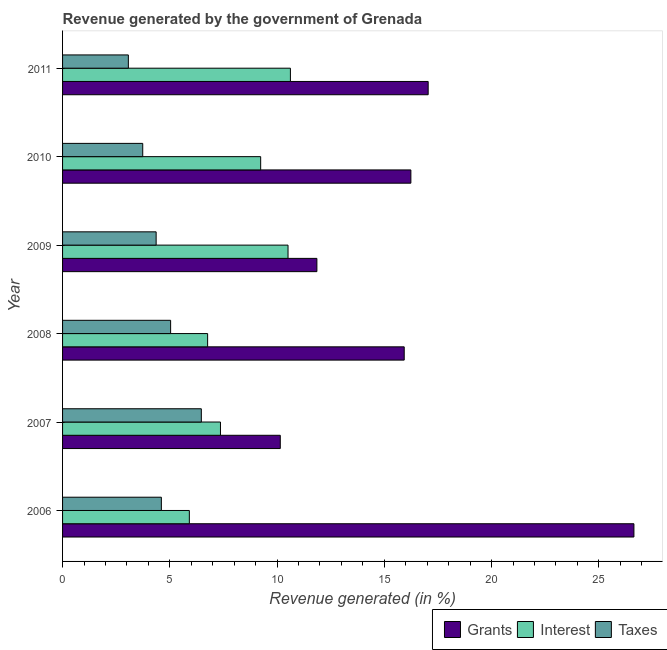What is the label of the 6th group of bars from the top?
Provide a short and direct response. 2006. What is the percentage of revenue generated by grants in 2008?
Your answer should be very brief. 15.93. Across all years, what is the maximum percentage of revenue generated by interest?
Your answer should be compact. 10.62. Across all years, what is the minimum percentage of revenue generated by taxes?
Your response must be concise. 3.07. In which year was the percentage of revenue generated by interest minimum?
Make the answer very short. 2006. What is the total percentage of revenue generated by interest in the graph?
Provide a short and direct response. 50.4. What is the difference between the percentage of revenue generated by taxes in 2006 and that in 2007?
Keep it short and to the point. -1.86. What is the difference between the percentage of revenue generated by grants in 2010 and the percentage of revenue generated by taxes in 2009?
Offer a terse response. 11.88. In the year 2011, what is the difference between the percentage of revenue generated by taxes and percentage of revenue generated by interest?
Give a very brief answer. -7.55. What is the ratio of the percentage of revenue generated by grants in 2006 to that in 2011?
Give a very brief answer. 1.56. What is the difference between the highest and the second highest percentage of revenue generated by taxes?
Make the answer very short. 1.43. What is the difference between the highest and the lowest percentage of revenue generated by grants?
Your answer should be very brief. 16.49. What does the 1st bar from the top in 2008 represents?
Your answer should be very brief. Taxes. What does the 3rd bar from the bottom in 2008 represents?
Provide a short and direct response. Taxes. Is it the case that in every year, the sum of the percentage of revenue generated by grants and percentage of revenue generated by interest is greater than the percentage of revenue generated by taxes?
Keep it short and to the point. Yes. Are all the bars in the graph horizontal?
Offer a very short reply. Yes. How many years are there in the graph?
Keep it short and to the point. 6. Does the graph contain any zero values?
Provide a succinct answer. No. How many legend labels are there?
Provide a succinct answer. 3. What is the title of the graph?
Make the answer very short. Revenue generated by the government of Grenada. What is the label or title of the X-axis?
Ensure brevity in your answer.  Revenue generated (in %). What is the Revenue generated (in %) of Grants in 2006?
Ensure brevity in your answer.  26.64. What is the Revenue generated (in %) of Interest in 2006?
Give a very brief answer. 5.91. What is the Revenue generated (in %) in Taxes in 2006?
Make the answer very short. 4.61. What is the Revenue generated (in %) of Grants in 2007?
Make the answer very short. 10.15. What is the Revenue generated (in %) in Interest in 2007?
Provide a succinct answer. 7.36. What is the Revenue generated (in %) in Taxes in 2007?
Offer a very short reply. 6.47. What is the Revenue generated (in %) of Grants in 2008?
Offer a terse response. 15.93. What is the Revenue generated (in %) in Interest in 2008?
Make the answer very short. 6.76. What is the Revenue generated (in %) in Taxes in 2008?
Offer a terse response. 5.04. What is the Revenue generated (in %) of Grants in 2009?
Offer a terse response. 11.86. What is the Revenue generated (in %) in Interest in 2009?
Give a very brief answer. 10.51. What is the Revenue generated (in %) in Taxes in 2009?
Provide a short and direct response. 4.36. What is the Revenue generated (in %) of Grants in 2010?
Your answer should be very brief. 16.24. What is the Revenue generated (in %) of Interest in 2010?
Keep it short and to the point. 9.24. What is the Revenue generated (in %) of Taxes in 2010?
Offer a terse response. 3.74. What is the Revenue generated (in %) in Grants in 2011?
Your answer should be compact. 17.04. What is the Revenue generated (in %) of Interest in 2011?
Offer a very short reply. 10.62. What is the Revenue generated (in %) of Taxes in 2011?
Ensure brevity in your answer.  3.07. Across all years, what is the maximum Revenue generated (in %) in Grants?
Keep it short and to the point. 26.64. Across all years, what is the maximum Revenue generated (in %) in Interest?
Ensure brevity in your answer.  10.62. Across all years, what is the maximum Revenue generated (in %) of Taxes?
Provide a succinct answer. 6.47. Across all years, what is the minimum Revenue generated (in %) in Grants?
Provide a succinct answer. 10.15. Across all years, what is the minimum Revenue generated (in %) of Interest?
Provide a succinct answer. 5.91. Across all years, what is the minimum Revenue generated (in %) in Taxes?
Give a very brief answer. 3.07. What is the total Revenue generated (in %) in Grants in the graph?
Make the answer very short. 97.85. What is the total Revenue generated (in %) in Interest in the graph?
Make the answer very short. 50.4. What is the total Revenue generated (in %) of Taxes in the graph?
Make the answer very short. 27.28. What is the difference between the Revenue generated (in %) in Grants in 2006 and that in 2007?
Ensure brevity in your answer.  16.49. What is the difference between the Revenue generated (in %) of Interest in 2006 and that in 2007?
Offer a very short reply. -1.45. What is the difference between the Revenue generated (in %) of Taxes in 2006 and that in 2007?
Provide a succinct answer. -1.86. What is the difference between the Revenue generated (in %) in Grants in 2006 and that in 2008?
Make the answer very short. 10.71. What is the difference between the Revenue generated (in %) of Interest in 2006 and that in 2008?
Provide a succinct answer. -0.85. What is the difference between the Revenue generated (in %) of Taxes in 2006 and that in 2008?
Offer a terse response. -0.43. What is the difference between the Revenue generated (in %) of Grants in 2006 and that in 2009?
Provide a succinct answer. 14.78. What is the difference between the Revenue generated (in %) of Interest in 2006 and that in 2009?
Your answer should be very brief. -4.6. What is the difference between the Revenue generated (in %) of Taxes in 2006 and that in 2009?
Keep it short and to the point. 0.24. What is the difference between the Revenue generated (in %) of Grants in 2006 and that in 2010?
Offer a terse response. 10.4. What is the difference between the Revenue generated (in %) of Interest in 2006 and that in 2010?
Offer a terse response. -3.33. What is the difference between the Revenue generated (in %) of Taxes in 2006 and that in 2010?
Your answer should be compact. 0.87. What is the difference between the Revenue generated (in %) in Grants in 2006 and that in 2011?
Offer a terse response. 9.59. What is the difference between the Revenue generated (in %) in Interest in 2006 and that in 2011?
Your answer should be very brief. -4.71. What is the difference between the Revenue generated (in %) in Taxes in 2006 and that in 2011?
Your answer should be very brief. 1.54. What is the difference between the Revenue generated (in %) in Grants in 2007 and that in 2008?
Your response must be concise. -5.78. What is the difference between the Revenue generated (in %) in Interest in 2007 and that in 2008?
Provide a short and direct response. 0.6. What is the difference between the Revenue generated (in %) in Taxes in 2007 and that in 2008?
Your answer should be very brief. 1.43. What is the difference between the Revenue generated (in %) of Grants in 2007 and that in 2009?
Ensure brevity in your answer.  -1.71. What is the difference between the Revenue generated (in %) in Interest in 2007 and that in 2009?
Your response must be concise. -3.15. What is the difference between the Revenue generated (in %) of Taxes in 2007 and that in 2009?
Keep it short and to the point. 2.11. What is the difference between the Revenue generated (in %) in Grants in 2007 and that in 2010?
Provide a succinct answer. -6.09. What is the difference between the Revenue generated (in %) of Interest in 2007 and that in 2010?
Keep it short and to the point. -1.87. What is the difference between the Revenue generated (in %) in Taxes in 2007 and that in 2010?
Your response must be concise. 2.73. What is the difference between the Revenue generated (in %) in Grants in 2007 and that in 2011?
Make the answer very short. -6.89. What is the difference between the Revenue generated (in %) in Interest in 2007 and that in 2011?
Your response must be concise. -3.26. What is the difference between the Revenue generated (in %) in Taxes in 2007 and that in 2011?
Keep it short and to the point. 3.4. What is the difference between the Revenue generated (in %) in Grants in 2008 and that in 2009?
Your answer should be very brief. 4.07. What is the difference between the Revenue generated (in %) of Interest in 2008 and that in 2009?
Your answer should be compact. -3.75. What is the difference between the Revenue generated (in %) of Taxes in 2008 and that in 2009?
Keep it short and to the point. 0.68. What is the difference between the Revenue generated (in %) of Grants in 2008 and that in 2010?
Your answer should be compact. -0.31. What is the difference between the Revenue generated (in %) in Interest in 2008 and that in 2010?
Your answer should be compact. -2.47. What is the difference between the Revenue generated (in %) of Taxes in 2008 and that in 2010?
Offer a terse response. 1.3. What is the difference between the Revenue generated (in %) in Grants in 2008 and that in 2011?
Your response must be concise. -1.12. What is the difference between the Revenue generated (in %) of Interest in 2008 and that in 2011?
Offer a very short reply. -3.86. What is the difference between the Revenue generated (in %) of Taxes in 2008 and that in 2011?
Offer a very short reply. 1.97. What is the difference between the Revenue generated (in %) of Grants in 2009 and that in 2010?
Provide a short and direct response. -4.38. What is the difference between the Revenue generated (in %) in Interest in 2009 and that in 2010?
Your response must be concise. 1.27. What is the difference between the Revenue generated (in %) of Taxes in 2009 and that in 2010?
Make the answer very short. 0.62. What is the difference between the Revenue generated (in %) in Grants in 2009 and that in 2011?
Offer a terse response. -5.19. What is the difference between the Revenue generated (in %) in Interest in 2009 and that in 2011?
Provide a succinct answer. -0.11. What is the difference between the Revenue generated (in %) in Taxes in 2009 and that in 2011?
Your answer should be very brief. 1.29. What is the difference between the Revenue generated (in %) in Grants in 2010 and that in 2011?
Your answer should be very brief. -0.81. What is the difference between the Revenue generated (in %) of Interest in 2010 and that in 2011?
Ensure brevity in your answer.  -1.39. What is the difference between the Revenue generated (in %) of Taxes in 2010 and that in 2011?
Offer a terse response. 0.67. What is the difference between the Revenue generated (in %) in Grants in 2006 and the Revenue generated (in %) in Interest in 2007?
Your answer should be compact. 19.27. What is the difference between the Revenue generated (in %) of Grants in 2006 and the Revenue generated (in %) of Taxes in 2007?
Your response must be concise. 20.17. What is the difference between the Revenue generated (in %) in Interest in 2006 and the Revenue generated (in %) in Taxes in 2007?
Give a very brief answer. -0.56. What is the difference between the Revenue generated (in %) of Grants in 2006 and the Revenue generated (in %) of Interest in 2008?
Your answer should be very brief. 19.87. What is the difference between the Revenue generated (in %) in Grants in 2006 and the Revenue generated (in %) in Taxes in 2008?
Make the answer very short. 21.6. What is the difference between the Revenue generated (in %) of Interest in 2006 and the Revenue generated (in %) of Taxes in 2008?
Provide a succinct answer. 0.87. What is the difference between the Revenue generated (in %) of Grants in 2006 and the Revenue generated (in %) of Interest in 2009?
Your response must be concise. 16.12. What is the difference between the Revenue generated (in %) of Grants in 2006 and the Revenue generated (in %) of Taxes in 2009?
Your answer should be very brief. 22.27. What is the difference between the Revenue generated (in %) in Interest in 2006 and the Revenue generated (in %) in Taxes in 2009?
Your answer should be compact. 1.55. What is the difference between the Revenue generated (in %) of Grants in 2006 and the Revenue generated (in %) of Interest in 2010?
Ensure brevity in your answer.  17.4. What is the difference between the Revenue generated (in %) of Grants in 2006 and the Revenue generated (in %) of Taxes in 2010?
Offer a terse response. 22.9. What is the difference between the Revenue generated (in %) in Interest in 2006 and the Revenue generated (in %) in Taxes in 2010?
Give a very brief answer. 2.17. What is the difference between the Revenue generated (in %) of Grants in 2006 and the Revenue generated (in %) of Interest in 2011?
Provide a short and direct response. 16.01. What is the difference between the Revenue generated (in %) in Grants in 2006 and the Revenue generated (in %) in Taxes in 2011?
Offer a very short reply. 23.57. What is the difference between the Revenue generated (in %) of Interest in 2006 and the Revenue generated (in %) of Taxes in 2011?
Your response must be concise. 2.84. What is the difference between the Revenue generated (in %) in Grants in 2007 and the Revenue generated (in %) in Interest in 2008?
Give a very brief answer. 3.39. What is the difference between the Revenue generated (in %) in Grants in 2007 and the Revenue generated (in %) in Taxes in 2008?
Your answer should be compact. 5.11. What is the difference between the Revenue generated (in %) of Interest in 2007 and the Revenue generated (in %) of Taxes in 2008?
Provide a short and direct response. 2.32. What is the difference between the Revenue generated (in %) of Grants in 2007 and the Revenue generated (in %) of Interest in 2009?
Your answer should be compact. -0.36. What is the difference between the Revenue generated (in %) of Grants in 2007 and the Revenue generated (in %) of Taxes in 2009?
Offer a terse response. 5.79. What is the difference between the Revenue generated (in %) in Interest in 2007 and the Revenue generated (in %) in Taxes in 2009?
Ensure brevity in your answer.  3. What is the difference between the Revenue generated (in %) of Grants in 2007 and the Revenue generated (in %) of Interest in 2010?
Keep it short and to the point. 0.91. What is the difference between the Revenue generated (in %) in Grants in 2007 and the Revenue generated (in %) in Taxes in 2010?
Give a very brief answer. 6.41. What is the difference between the Revenue generated (in %) of Interest in 2007 and the Revenue generated (in %) of Taxes in 2010?
Offer a very short reply. 3.62. What is the difference between the Revenue generated (in %) in Grants in 2007 and the Revenue generated (in %) in Interest in 2011?
Offer a terse response. -0.47. What is the difference between the Revenue generated (in %) of Grants in 2007 and the Revenue generated (in %) of Taxes in 2011?
Give a very brief answer. 7.08. What is the difference between the Revenue generated (in %) in Interest in 2007 and the Revenue generated (in %) in Taxes in 2011?
Give a very brief answer. 4.29. What is the difference between the Revenue generated (in %) in Grants in 2008 and the Revenue generated (in %) in Interest in 2009?
Provide a short and direct response. 5.42. What is the difference between the Revenue generated (in %) in Grants in 2008 and the Revenue generated (in %) in Taxes in 2009?
Provide a short and direct response. 11.57. What is the difference between the Revenue generated (in %) in Interest in 2008 and the Revenue generated (in %) in Taxes in 2009?
Offer a terse response. 2.4. What is the difference between the Revenue generated (in %) in Grants in 2008 and the Revenue generated (in %) in Interest in 2010?
Your response must be concise. 6.69. What is the difference between the Revenue generated (in %) of Grants in 2008 and the Revenue generated (in %) of Taxes in 2010?
Your answer should be compact. 12.19. What is the difference between the Revenue generated (in %) in Interest in 2008 and the Revenue generated (in %) in Taxes in 2010?
Your answer should be very brief. 3.03. What is the difference between the Revenue generated (in %) of Grants in 2008 and the Revenue generated (in %) of Interest in 2011?
Keep it short and to the point. 5.31. What is the difference between the Revenue generated (in %) in Grants in 2008 and the Revenue generated (in %) in Taxes in 2011?
Make the answer very short. 12.86. What is the difference between the Revenue generated (in %) of Interest in 2008 and the Revenue generated (in %) of Taxes in 2011?
Offer a very short reply. 3.7. What is the difference between the Revenue generated (in %) of Grants in 2009 and the Revenue generated (in %) of Interest in 2010?
Your response must be concise. 2.62. What is the difference between the Revenue generated (in %) of Grants in 2009 and the Revenue generated (in %) of Taxes in 2010?
Provide a short and direct response. 8.12. What is the difference between the Revenue generated (in %) in Interest in 2009 and the Revenue generated (in %) in Taxes in 2010?
Provide a short and direct response. 6.77. What is the difference between the Revenue generated (in %) of Grants in 2009 and the Revenue generated (in %) of Interest in 2011?
Keep it short and to the point. 1.23. What is the difference between the Revenue generated (in %) in Grants in 2009 and the Revenue generated (in %) in Taxes in 2011?
Your answer should be very brief. 8.79. What is the difference between the Revenue generated (in %) of Interest in 2009 and the Revenue generated (in %) of Taxes in 2011?
Your answer should be compact. 7.44. What is the difference between the Revenue generated (in %) in Grants in 2010 and the Revenue generated (in %) in Interest in 2011?
Offer a very short reply. 5.62. What is the difference between the Revenue generated (in %) of Grants in 2010 and the Revenue generated (in %) of Taxes in 2011?
Ensure brevity in your answer.  13.17. What is the difference between the Revenue generated (in %) of Interest in 2010 and the Revenue generated (in %) of Taxes in 2011?
Your answer should be compact. 6.17. What is the average Revenue generated (in %) of Grants per year?
Ensure brevity in your answer.  16.31. What is the average Revenue generated (in %) of Interest per year?
Ensure brevity in your answer.  8.4. What is the average Revenue generated (in %) of Taxes per year?
Ensure brevity in your answer.  4.55. In the year 2006, what is the difference between the Revenue generated (in %) of Grants and Revenue generated (in %) of Interest?
Provide a succinct answer. 20.73. In the year 2006, what is the difference between the Revenue generated (in %) in Grants and Revenue generated (in %) in Taxes?
Ensure brevity in your answer.  22.03. In the year 2006, what is the difference between the Revenue generated (in %) of Interest and Revenue generated (in %) of Taxes?
Provide a succinct answer. 1.3. In the year 2007, what is the difference between the Revenue generated (in %) of Grants and Revenue generated (in %) of Interest?
Make the answer very short. 2.79. In the year 2007, what is the difference between the Revenue generated (in %) in Grants and Revenue generated (in %) in Taxes?
Offer a terse response. 3.68. In the year 2007, what is the difference between the Revenue generated (in %) in Interest and Revenue generated (in %) in Taxes?
Offer a very short reply. 0.89. In the year 2008, what is the difference between the Revenue generated (in %) in Grants and Revenue generated (in %) in Interest?
Offer a very short reply. 9.16. In the year 2008, what is the difference between the Revenue generated (in %) of Grants and Revenue generated (in %) of Taxes?
Ensure brevity in your answer.  10.89. In the year 2008, what is the difference between the Revenue generated (in %) in Interest and Revenue generated (in %) in Taxes?
Make the answer very short. 1.72. In the year 2009, what is the difference between the Revenue generated (in %) in Grants and Revenue generated (in %) in Interest?
Provide a succinct answer. 1.35. In the year 2009, what is the difference between the Revenue generated (in %) in Grants and Revenue generated (in %) in Taxes?
Your response must be concise. 7.49. In the year 2009, what is the difference between the Revenue generated (in %) of Interest and Revenue generated (in %) of Taxes?
Your answer should be compact. 6.15. In the year 2010, what is the difference between the Revenue generated (in %) in Grants and Revenue generated (in %) in Interest?
Ensure brevity in your answer.  7. In the year 2010, what is the difference between the Revenue generated (in %) of Grants and Revenue generated (in %) of Taxes?
Provide a succinct answer. 12.5. In the year 2010, what is the difference between the Revenue generated (in %) of Interest and Revenue generated (in %) of Taxes?
Give a very brief answer. 5.5. In the year 2011, what is the difference between the Revenue generated (in %) of Grants and Revenue generated (in %) of Interest?
Your response must be concise. 6.42. In the year 2011, what is the difference between the Revenue generated (in %) in Grants and Revenue generated (in %) in Taxes?
Ensure brevity in your answer.  13.98. In the year 2011, what is the difference between the Revenue generated (in %) of Interest and Revenue generated (in %) of Taxes?
Offer a very short reply. 7.55. What is the ratio of the Revenue generated (in %) in Grants in 2006 to that in 2007?
Your response must be concise. 2.62. What is the ratio of the Revenue generated (in %) of Interest in 2006 to that in 2007?
Keep it short and to the point. 0.8. What is the ratio of the Revenue generated (in %) in Taxes in 2006 to that in 2007?
Make the answer very short. 0.71. What is the ratio of the Revenue generated (in %) in Grants in 2006 to that in 2008?
Your answer should be compact. 1.67. What is the ratio of the Revenue generated (in %) of Interest in 2006 to that in 2008?
Your answer should be very brief. 0.87. What is the ratio of the Revenue generated (in %) in Taxes in 2006 to that in 2008?
Offer a very short reply. 0.91. What is the ratio of the Revenue generated (in %) of Grants in 2006 to that in 2009?
Provide a short and direct response. 2.25. What is the ratio of the Revenue generated (in %) in Interest in 2006 to that in 2009?
Ensure brevity in your answer.  0.56. What is the ratio of the Revenue generated (in %) in Taxes in 2006 to that in 2009?
Your response must be concise. 1.06. What is the ratio of the Revenue generated (in %) of Grants in 2006 to that in 2010?
Provide a succinct answer. 1.64. What is the ratio of the Revenue generated (in %) of Interest in 2006 to that in 2010?
Ensure brevity in your answer.  0.64. What is the ratio of the Revenue generated (in %) in Taxes in 2006 to that in 2010?
Your answer should be compact. 1.23. What is the ratio of the Revenue generated (in %) in Grants in 2006 to that in 2011?
Give a very brief answer. 1.56. What is the ratio of the Revenue generated (in %) in Interest in 2006 to that in 2011?
Provide a short and direct response. 0.56. What is the ratio of the Revenue generated (in %) of Taxes in 2006 to that in 2011?
Offer a terse response. 1.5. What is the ratio of the Revenue generated (in %) of Grants in 2007 to that in 2008?
Make the answer very short. 0.64. What is the ratio of the Revenue generated (in %) of Interest in 2007 to that in 2008?
Your answer should be compact. 1.09. What is the ratio of the Revenue generated (in %) of Taxes in 2007 to that in 2008?
Your answer should be compact. 1.28. What is the ratio of the Revenue generated (in %) in Grants in 2007 to that in 2009?
Your answer should be very brief. 0.86. What is the ratio of the Revenue generated (in %) of Interest in 2007 to that in 2009?
Provide a short and direct response. 0.7. What is the ratio of the Revenue generated (in %) in Taxes in 2007 to that in 2009?
Keep it short and to the point. 1.48. What is the ratio of the Revenue generated (in %) of Grants in 2007 to that in 2010?
Your answer should be very brief. 0.63. What is the ratio of the Revenue generated (in %) in Interest in 2007 to that in 2010?
Give a very brief answer. 0.8. What is the ratio of the Revenue generated (in %) in Taxes in 2007 to that in 2010?
Your response must be concise. 1.73. What is the ratio of the Revenue generated (in %) of Grants in 2007 to that in 2011?
Your response must be concise. 0.6. What is the ratio of the Revenue generated (in %) of Interest in 2007 to that in 2011?
Give a very brief answer. 0.69. What is the ratio of the Revenue generated (in %) of Taxes in 2007 to that in 2011?
Offer a very short reply. 2.11. What is the ratio of the Revenue generated (in %) in Grants in 2008 to that in 2009?
Offer a terse response. 1.34. What is the ratio of the Revenue generated (in %) in Interest in 2008 to that in 2009?
Provide a short and direct response. 0.64. What is the ratio of the Revenue generated (in %) of Taxes in 2008 to that in 2009?
Keep it short and to the point. 1.15. What is the ratio of the Revenue generated (in %) of Grants in 2008 to that in 2010?
Provide a succinct answer. 0.98. What is the ratio of the Revenue generated (in %) in Interest in 2008 to that in 2010?
Give a very brief answer. 0.73. What is the ratio of the Revenue generated (in %) of Taxes in 2008 to that in 2010?
Ensure brevity in your answer.  1.35. What is the ratio of the Revenue generated (in %) in Grants in 2008 to that in 2011?
Provide a short and direct response. 0.93. What is the ratio of the Revenue generated (in %) in Interest in 2008 to that in 2011?
Provide a short and direct response. 0.64. What is the ratio of the Revenue generated (in %) in Taxes in 2008 to that in 2011?
Offer a terse response. 1.64. What is the ratio of the Revenue generated (in %) of Grants in 2009 to that in 2010?
Make the answer very short. 0.73. What is the ratio of the Revenue generated (in %) of Interest in 2009 to that in 2010?
Provide a short and direct response. 1.14. What is the ratio of the Revenue generated (in %) in Taxes in 2009 to that in 2010?
Give a very brief answer. 1.17. What is the ratio of the Revenue generated (in %) of Grants in 2009 to that in 2011?
Offer a very short reply. 0.7. What is the ratio of the Revenue generated (in %) of Taxes in 2009 to that in 2011?
Offer a very short reply. 1.42. What is the ratio of the Revenue generated (in %) in Grants in 2010 to that in 2011?
Your answer should be compact. 0.95. What is the ratio of the Revenue generated (in %) in Interest in 2010 to that in 2011?
Offer a very short reply. 0.87. What is the ratio of the Revenue generated (in %) in Taxes in 2010 to that in 2011?
Keep it short and to the point. 1.22. What is the difference between the highest and the second highest Revenue generated (in %) in Grants?
Provide a succinct answer. 9.59. What is the difference between the highest and the second highest Revenue generated (in %) of Interest?
Provide a succinct answer. 0.11. What is the difference between the highest and the second highest Revenue generated (in %) in Taxes?
Keep it short and to the point. 1.43. What is the difference between the highest and the lowest Revenue generated (in %) of Grants?
Your answer should be compact. 16.49. What is the difference between the highest and the lowest Revenue generated (in %) of Interest?
Your answer should be very brief. 4.71. What is the difference between the highest and the lowest Revenue generated (in %) in Taxes?
Your response must be concise. 3.4. 